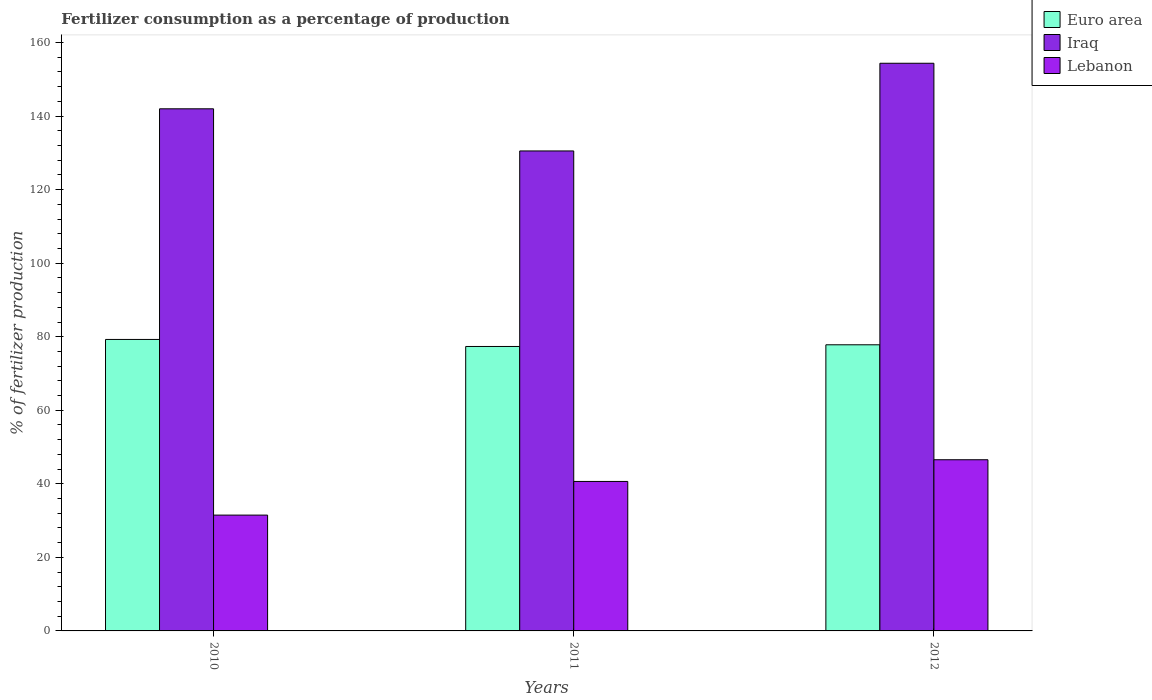How many different coloured bars are there?
Ensure brevity in your answer.  3. How many groups of bars are there?
Give a very brief answer. 3. Are the number of bars per tick equal to the number of legend labels?
Your response must be concise. Yes. Are the number of bars on each tick of the X-axis equal?
Offer a very short reply. Yes. How many bars are there on the 2nd tick from the right?
Your response must be concise. 3. What is the label of the 2nd group of bars from the left?
Give a very brief answer. 2011. In how many cases, is the number of bars for a given year not equal to the number of legend labels?
Offer a terse response. 0. What is the percentage of fertilizers consumed in Iraq in 2011?
Keep it short and to the point. 130.53. Across all years, what is the maximum percentage of fertilizers consumed in Iraq?
Give a very brief answer. 154.37. Across all years, what is the minimum percentage of fertilizers consumed in Euro area?
Offer a terse response. 77.35. In which year was the percentage of fertilizers consumed in Euro area maximum?
Offer a terse response. 2010. In which year was the percentage of fertilizers consumed in Euro area minimum?
Keep it short and to the point. 2011. What is the total percentage of fertilizers consumed in Lebanon in the graph?
Give a very brief answer. 118.7. What is the difference between the percentage of fertilizers consumed in Euro area in 2010 and that in 2012?
Make the answer very short. 1.45. What is the difference between the percentage of fertilizers consumed in Euro area in 2011 and the percentage of fertilizers consumed in Iraq in 2012?
Keep it short and to the point. -77.02. What is the average percentage of fertilizers consumed in Iraq per year?
Offer a terse response. 142.3. In the year 2010, what is the difference between the percentage of fertilizers consumed in Iraq and percentage of fertilizers consumed in Lebanon?
Provide a succinct answer. 110.49. In how many years, is the percentage of fertilizers consumed in Iraq greater than 8 %?
Offer a terse response. 3. What is the ratio of the percentage of fertilizers consumed in Euro area in 2010 to that in 2012?
Give a very brief answer. 1.02. Is the percentage of fertilizers consumed in Iraq in 2010 less than that in 2011?
Make the answer very short. No. Is the difference between the percentage of fertilizers consumed in Iraq in 2011 and 2012 greater than the difference between the percentage of fertilizers consumed in Lebanon in 2011 and 2012?
Keep it short and to the point. No. What is the difference between the highest and the second highest percentage of fertilizers consumed in Lebanon?
Your response must be concise. 5.9. What is the difference between the highest and the lowest percentage of fertilizers consumed in Iraq?
Provide a short and direct response. 23.84. What does the 3rd bar from the left in 2010 represents?
Give a very brief answer. Lebanon. What does the 1st bar from the right in 2012 represents?
Offer a very short reply. Lebanon. How many years are there in the graph?
Make the answer very short. 3. Where does the legend appear in the graph?
Offer a terse response. Top right. How many legend labels are there?
Provide a short and direct response. 3. What is the title of the graph?
Ensure brevity in your answer.  Fertilizer consumption as a percentage of production. Does "Channel Islands" appear as one of the legend labels in the graph?
Your answer should be very brief. No. What is the label or title of the X-axis?
Keep it short and to the point. Years. What is the label or title of the Y-axis?
Provide a short and direct response. % of fertilizer production. What is the % of fertilizer production of Euro area in 2010?
Make the answer very short. 79.26. What is the % of fertilizer production in Iraq in 2010?
Your answer should be compact. 141.99. What is the % of fertilizer production in Lebanon in 2010?
Offer a terse response. 31.5. What is the % of fertilizer production in Euro area in 2011?
Give a very brief answer. 77.35. What is the % of fertilizer production of Iraq in 2011?
Your response must be concise. 130.53. What is the % of fertilizer production of Lebanon in 2011?
Ensure brevity in your answer.  40.65. What is the % of fertilizer production in Euro area in 2012?
Offer a very short reply. 77.81. What is the % of fertilizer production in Iraq in 2012?
Your response must be concise. 154.37. What is the % of fertilizer production of Lebanon in 2012?
Keep it short and to the point. 46.55. Across all years, what is the maximum % of fertilizer production of Euro area?
Your response must be concise. 79.26. Across all years, what is the maximum % of fertilizer production of Iraq?
Ensure brevity in your answer.  154.37. Across all years, what is the maximum % of fertilizer production in Lebanon?
Provide a succinct answer. 46.55. Across all years, what is the minimum % of fertilizer production of Euro area?
Your answer should be very brief. 77.35. Across all years, what is the minimum % of fertilizer production in Iraq?
Ensure brevity in your answer.  130.53. Across all years, what is the minimum % of fertilizer production of Lebanon?
Offer a very short reply. 31.5. What is the total % of fertilizer production in Euro area in the graph?
Your answer should be very brief. 234.43. What is the total % of fertilizer production in Iraq in the graph?
Make the answer very short. 426.89. What is the total % of fertilizer production of Lebanon in the graph?
Provide a succinct answer. 118.7. What is the difference between the % of fertilizer production in Euro area in 2010 and that in 2011?
Your answer should be very brief. 1.91. What is the difference between the % of fertilizer production of Iraq in 2010 and that in 2011?
Your answer should be very brief. 11.46. What is the difference between the % of fertilizer production of Lebanon in 2010 and that in 2011?
Make the answer very short. -9.15. What is the difference between the % of fertilizer production of Euro area in 2010 and that in 2012?
Your answer should be compact. 1.45. What is the difference between the % of fertilizer production in Iraq in 2010 and that in 2012?
Provide a short and direct response. -12.38. What is the difference between the % of fertilizer production in Lebanon in 2010 and that in 2012?
Provide a succinct answer. -15.05. What is the difference between the % of fertilizer production of Euro area in 2011 and that in 2012?
Your answer should be very brief. -0.46. What is the difference between the % of fertilizer production of Iraq in 2011 and that in 2012?
Provide a short and direct response. -23.84. What is the difference between the % of fertilizer production of Lebanon in 2011 and that in 2012?
Make the answer very short. -5.9. What is the difference between the % of fertilizer production in Euro area in 2010 and the % of fertilizer production in Iraq in 2011?
Offer a terse response. -51.26. What is the difference between the % of fertilizer production of Euro area in 2010 and the % of fertilizer production of Lebanon in 2011?
Provide a succinct answer. 38.62. What is the difference between the % of fertilizer production of Iraq in 2010 and the % of fertilizer production of Lebanon in 2011?
Provide a succinct answer. 101.34. What is the difference between the % of fertilizer production in Euro area in 2010 and the % of fertilizer production in Iraq in 2012?
Provide a short and direct response. -75.11. What is the difference between the % of fertilizer production in Euro area in 2010 and the % of fertilizer production in Lebanon in 2012?
Offer a terse response. 32.71. What is the difference between the % of fertilizer production of Iraq in 2010 and the % of fertilizer production of Lebanon in 2012?
Ensure brevity in your answer.  95.44. What is the difference between the % of fertilizer production of Euro area in 2011 and the % of fertilizer production of Iraq in 2012?
Offer a very short reply. -77.02. What is the difference between the % of fertilizer production in Euro area in 2011 and the % of fertilizer production in Lebanon in 2012?
Give a very brief answer. 30.8. What is the difference between the % of fertilizer production of Iraq in 2011 and the % of fertilizer production of Lebanon in 2012?
Your response must be concise. 83.98. What is the average % of fertilizer production of Euro area per year?
Make the answer very short. 78.14. What is the average % of fertilizer production of Iraq per year?
Ensure brevity in your answer.  142.3. What is the average % of fertilizer production in Lebanon per year?
Provide a succinct answer. 39.57. In the year 2010, what is the difference between the % of fertilizer production in Euro area and % of fertilizer production in Iraq?
Provide a short and direct response. -62.72. In the year 2010, what is the difference between the % of fertilizer production of Euro area and % of fertilizer production of Lebanon?
Ensure brevity in your answer.  47.77. In the year 2010, what is the difference between the % of fertilizer production in Iraq and % of fertilizer production in Lebanon?
Provide a short and direct response. 110.49. In the year 2011, what is the difference between the % of fertilizer production in Euro area and % of fertilizer production in Iraq?
Offer a very short reply. -53.17. In the year 2011, what is the difference between the % of fertilizer production in Euro area and % of fertilizer production in Lebanon?
Provide a short and direct response. 36.7. In the year 2011, what is the difference between the % of fertilizer production of Iraq and % of fertilizer production of Lebanon?
Give a very brief answer. 89.88. In the year 2012, what is the difference between the % of fertilizer production in Euro area and % of fertilizer production in Iraq?
Offer a very short reply. -76.56. In the year 2012, what is the difference between the % of fertilizer production in Euro area and % of fertilizer production in Lebanon?
Keep it short and to the point. 31.26. In the year 2012, what is the difference between the % of fertilizer production of Iraq and % of fertilizer production of Lebanon?
Make the answer very short. 107.82. What is the ratio of the % of fertilizer production in Euro area in 2010 to that in 2011?
Make the answer very short. 1.02. What is the ratio of the % of fertilizer production of Iraq in 2010 to that in 2011?
Offer a very short reply. 1.09. What is the ratio of the % of fertilizer production in Lebanon in 2010 to that in 2011?
Ensure brevity in your answer.  0.77. What is the ratio of the % of fertilizer production of Euro area in 2010 to that in 2012?
Your answer should be very brief. 1.02. What is the ratio of the % of fertilizer production of Iraq in 2010 to that in 2012?
Give a very brief answer. 0.92. What is the ratio of the % of fertilizer production of Lebanon in 2010 to that in 2012?
Offer a terse response. 0.68. What is the ratio of the % of fertilizer production in Iraq in 2011 to that in 2012?
Keep it short and to the point. 0.85. What is the ratio of the % of fertilizer production of Lebanon in 2011 to that in 2012?
Make the answer very short. 0.87. What is the difference between the highest and the second highest % of fertilizer production of Euro area?
Ensure brevity in your answer.  1.45. What is the difference between the highest and the second highest % of fertilizer production of Iraq?
Make the answer very short. 12.38. What is the difference between the highest and the second highest % of fertilizer production in Lebanon?
Your answer should be very brief. 5.9. What is the difference between the highest and the lowest % of fertilizer production of Euro area?
Your answer should be very brief. 1.91. What is the difference between the highest and the lowest % of fertilizer production of Iraq?
Make the answer very short. 23.84. What is the difference between the highest and the lowest % of fertilizer production of Lebanon?
Your response must be concise. 15.05. 